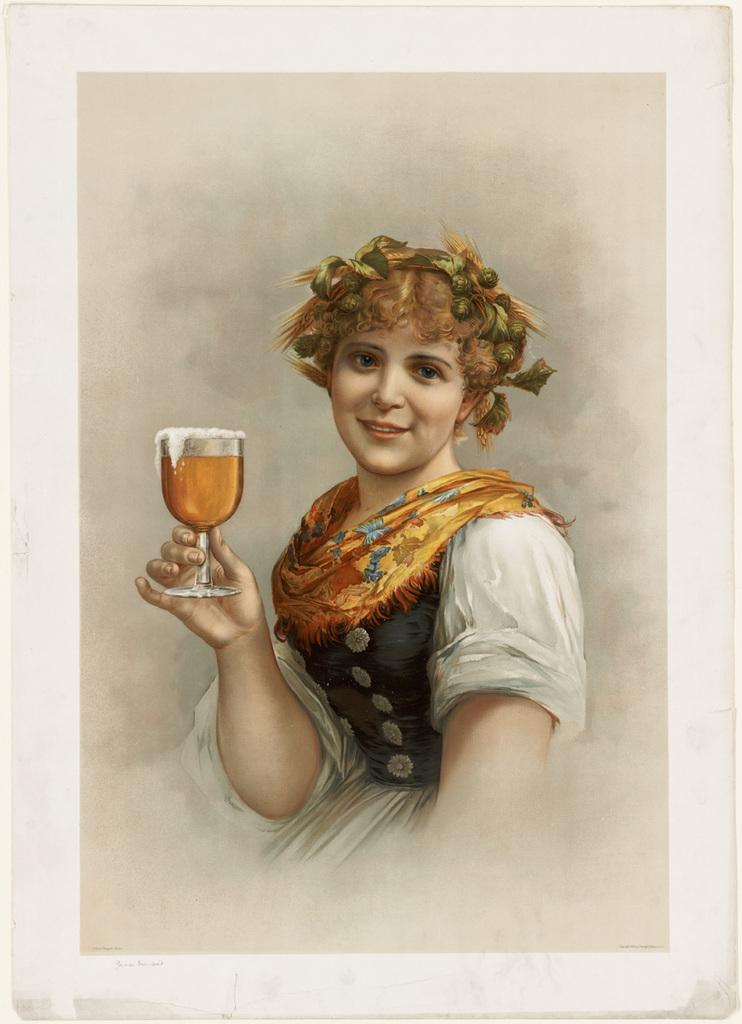What object is visible in the image that typically holds a photograph? There is a photo frame in the image. Who is featured in the photo frame? A woman is present in the photo frame. What is the woman wearing in the photo frame? The woman is wearing a white and black dress. What is the woman holding in the photo frame? The woman is holding a glass containing liquid. What expression does the woman have in the photo frame? The woman is smiling. Is there a fight happening between the woman and someone else in the photo frame? No, there is no fight depicted in the photo frame; the woman is smiling and holding a glass. What type of wrench is the woman using to fix the glass in the photo frame? There is no wrench present in the photo frame; the woman is simply holding a glass containing liquid. 